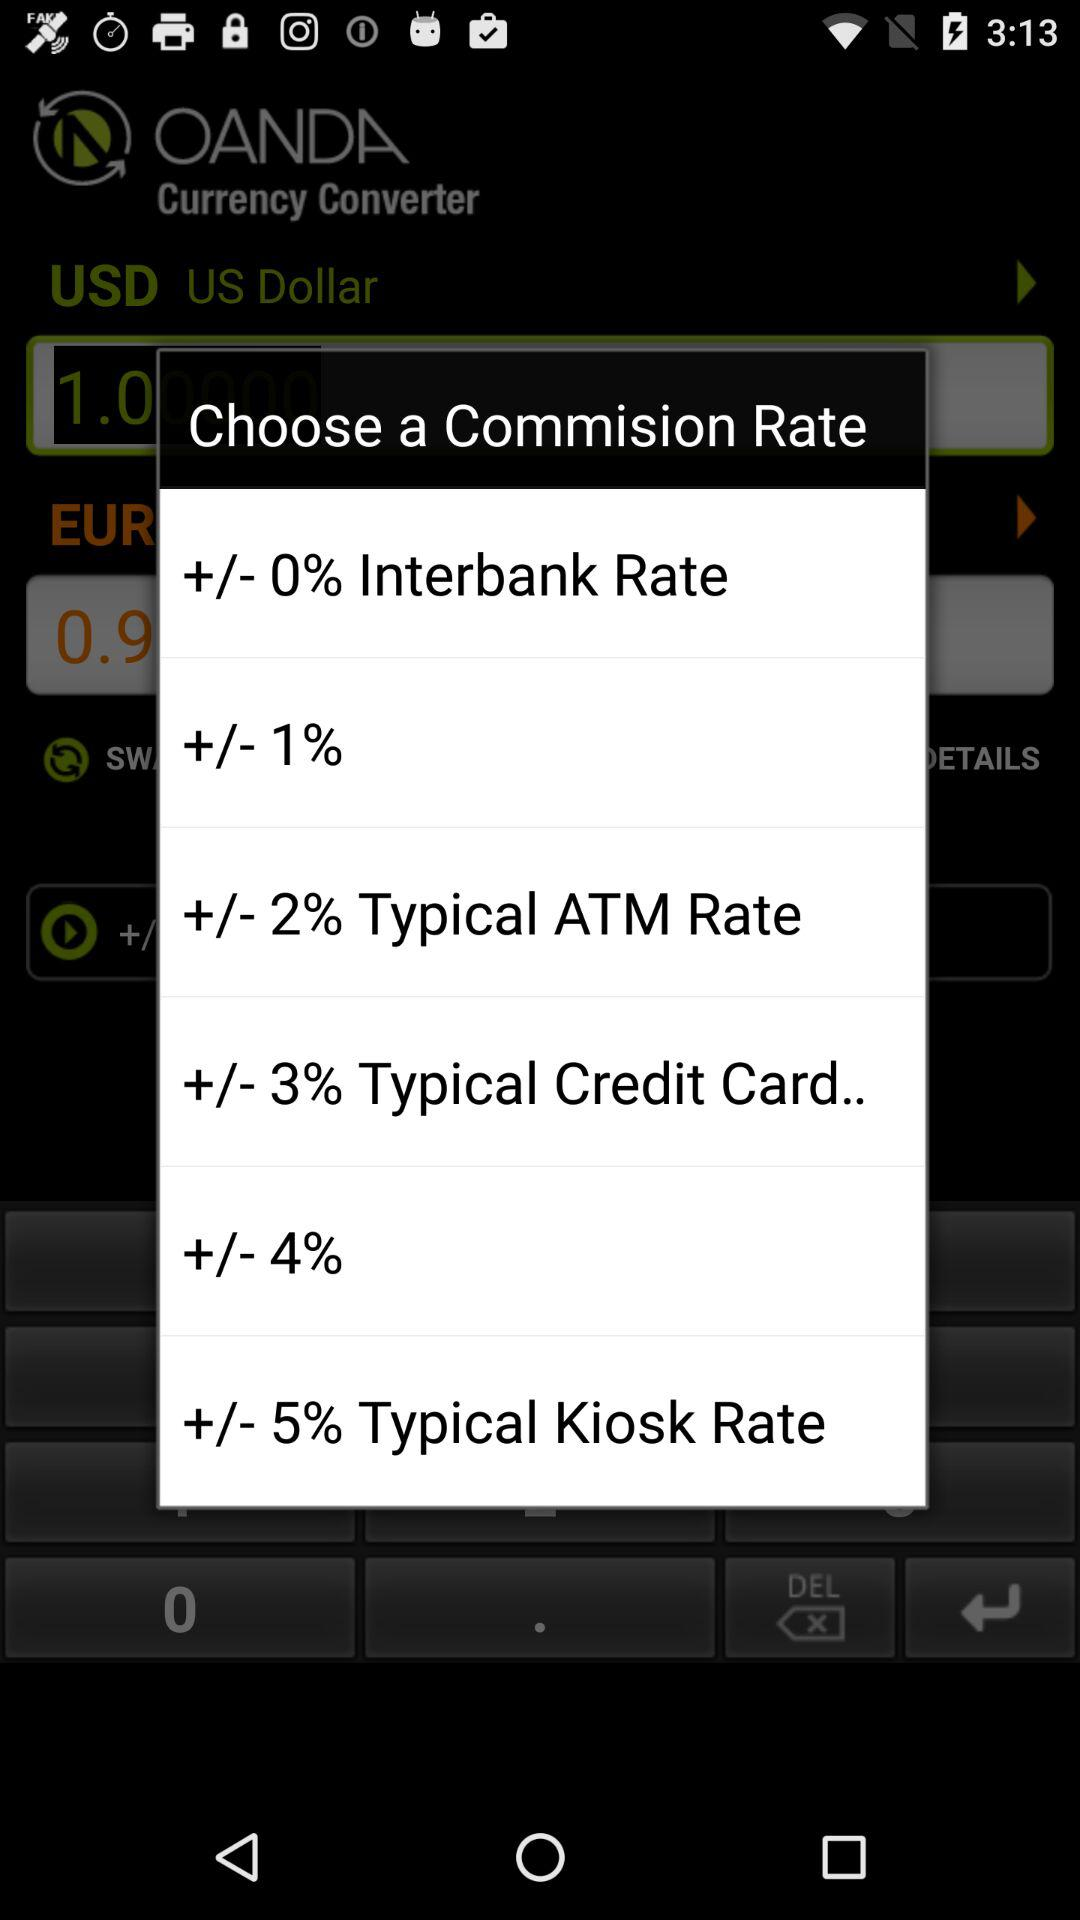What is the commission rate for "Credit Card"? The commission rate for "Credit Card" is "+/- 3% ". 